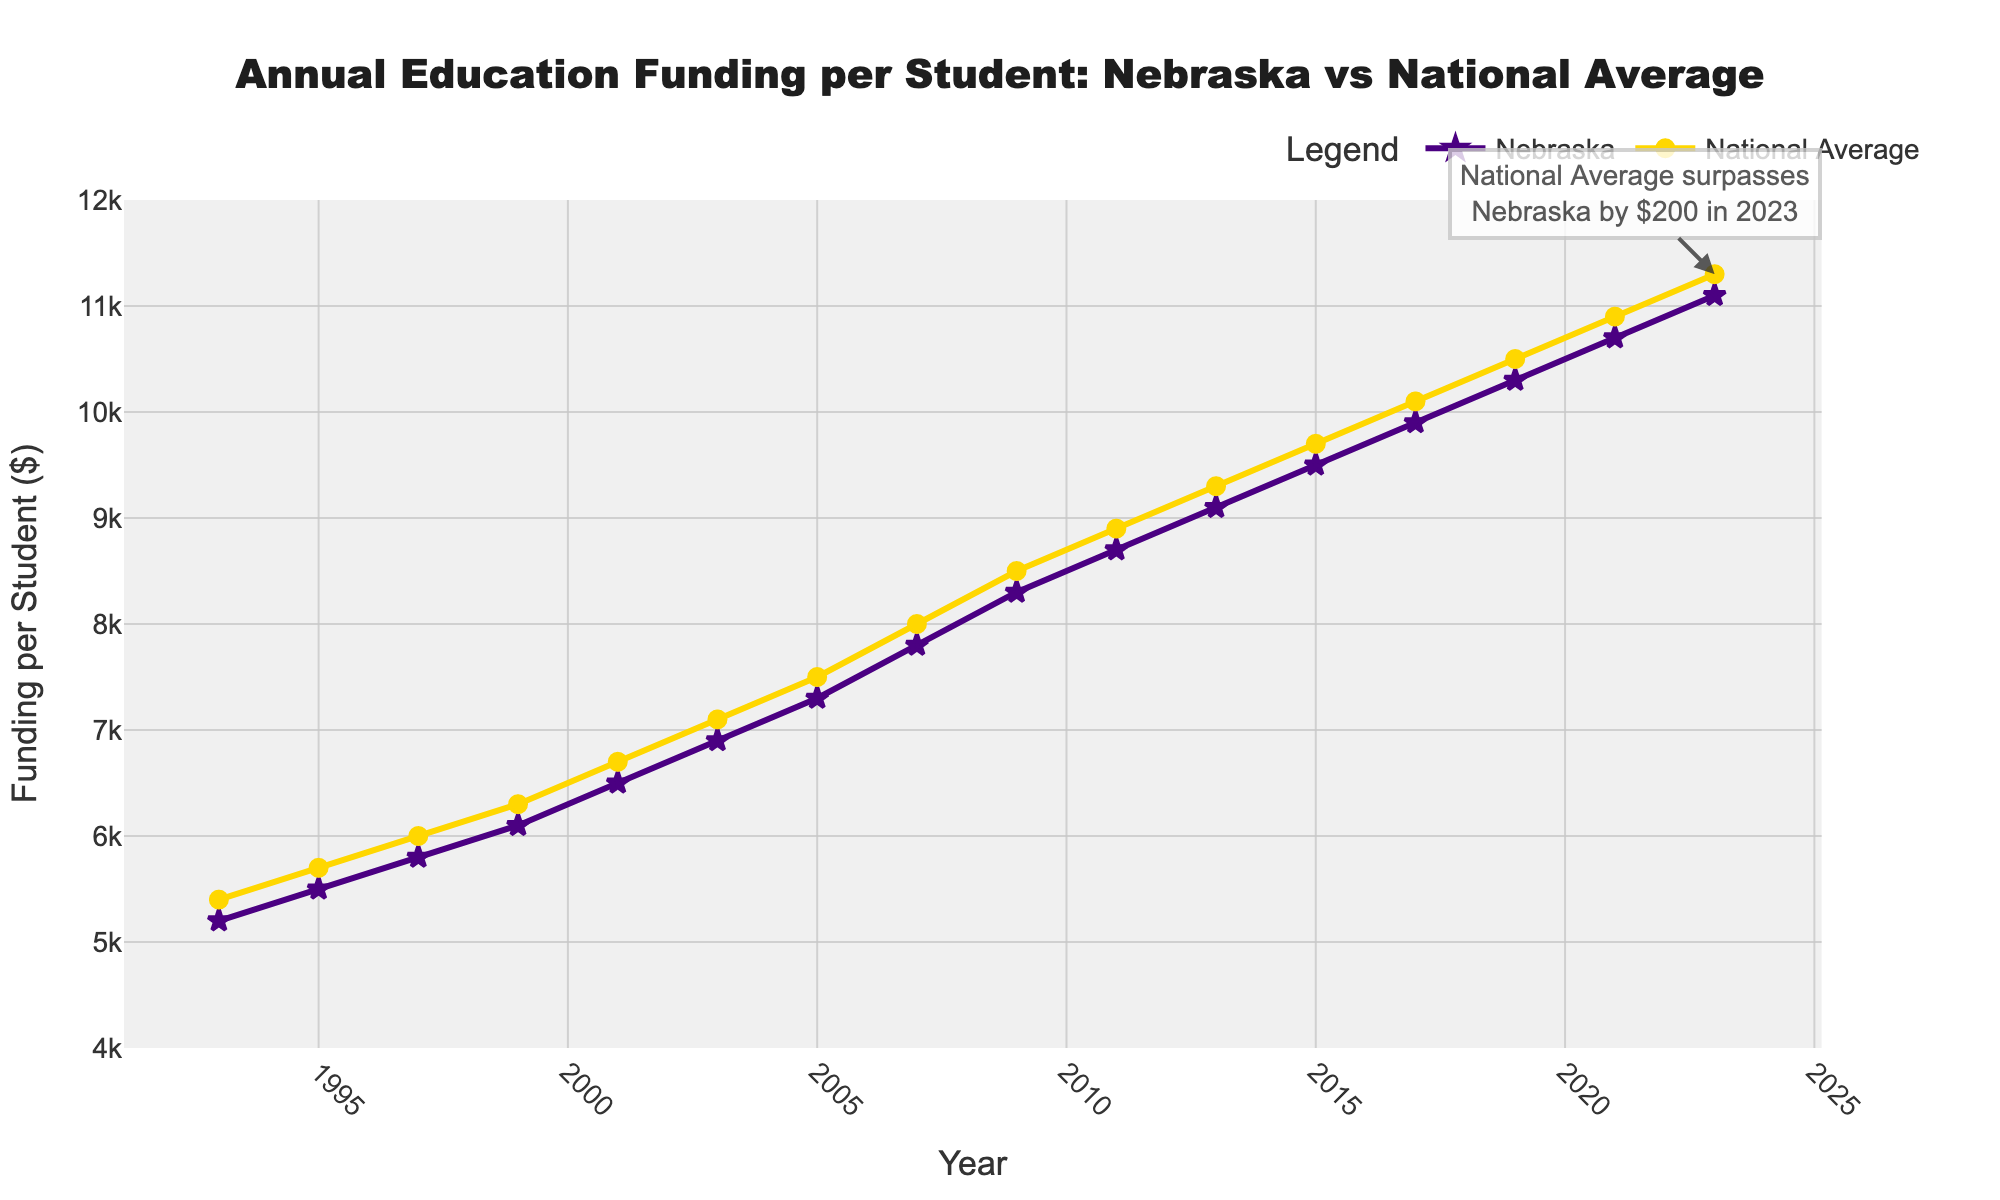What is the difference in education funding per student between Nebraska and the national average in 2023? By looking at the end of the lines for both Nebraska and the National Average data points in the year 2023, we can see that Nebraska's funding is $11,100 and the National Average is $11,300. The difference is $11,300 - $11,100 = $200.
Answer: $200 Which year did Nebraska's funding per student first exceed $10,000? By observing the Nebraska line, we can see the data point labeled with $10,300 in the year 2019. Thus, 2019 is the year when Nebraska's funding per student first exceeded $10,000.
Answer: 2019 What is the average national funding per student over the entire period shown? To compute the average, sum all the national average funding values and divide by the number of years (16 data points). The calculation is: (5400 + 5700 + 6000 + 6300 + 6700 + 7100 + 7500 + 8000 + 8500 + 8900 + 9300 + 9700 + 10100 + 10500 + 10900 + 11300)/16 = 81312/16 = 5082
Answer: 5082 How does the trend in Nebraska's funding compare to the national average over the period shown? Visually inspect both lines on the chart; both show an increasing trend over time. The lines rise consistently, indicating that both Nebraska's and the national average funding have increased over the past 30 years, with the national trend typically maintaining a slightly higher value than Nebraska's.
Answer: Both increasing In which years was Nebraska's funding per student equal to or more than the national average? By examining the line chart, which shows points where both lines either cross or Nebraska's line is above the national average, we find that Nebraska's funding was nearly equal to or more than the national average only in the early years around 1993. After 1993, the national average funding per student consistently stayed higher than Nebraska's.
Answer: 1993 In 2007, by how much did the national average funding per student surpass Nebraska's funding per student? By checking the data point for 2007, we see that Nebraska's funding per student was $7,800 and the National Average was $8,000. Therefore, the national average surpassed Nebraska's funding by $8,000 - $7,800 = $200.
Answer: $200 Calculate the percentage increase in funding per student for Nebraska from 1993 to 2023. First, find the funding values for Nebraska in 1993 and 2023, which are $5,200 and $11,100, respectively. Then calculate the increase: $11,100 - $5,200 = $5,900. To find the percentage increase, use the formula: (increase/original value) * 100 = ($5,900 / $5,200) * 100 = 113.46%.
Answer: 113.46% At which point in the graph do the lines for Nebraska and the national average funding come closest? By visually inspecting the lines, we see that they are closest at the beginning of the chart, specifically around the year 1993, when the points are closest to each other.
Answer: 1993 